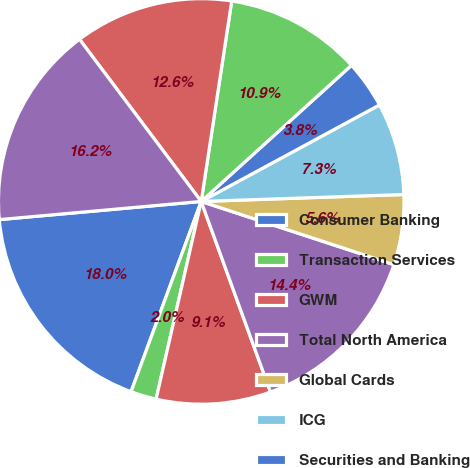<chart> <loc_0><loc_0><loc_500><loc_500><pie_chart><fcel>Consumer Banking<fcel>Transaction Services<fcel>GWM<fcel>Total North America<fcel>Global Cards<fcel>ICG<fcel>Securities and Banking<fcel>Total EMEA<fcel>Total Latin America<fcel>Total Asia<nl><fcel>17.95%<fcel>2.05%<fcel>9.12%<fcel>14.41%<fcel>5.59%<fcel>7.35%<fcel>3.82%<fcel>10.88%<fcel>12.65%<fcel>16.18%<nl></chart> 